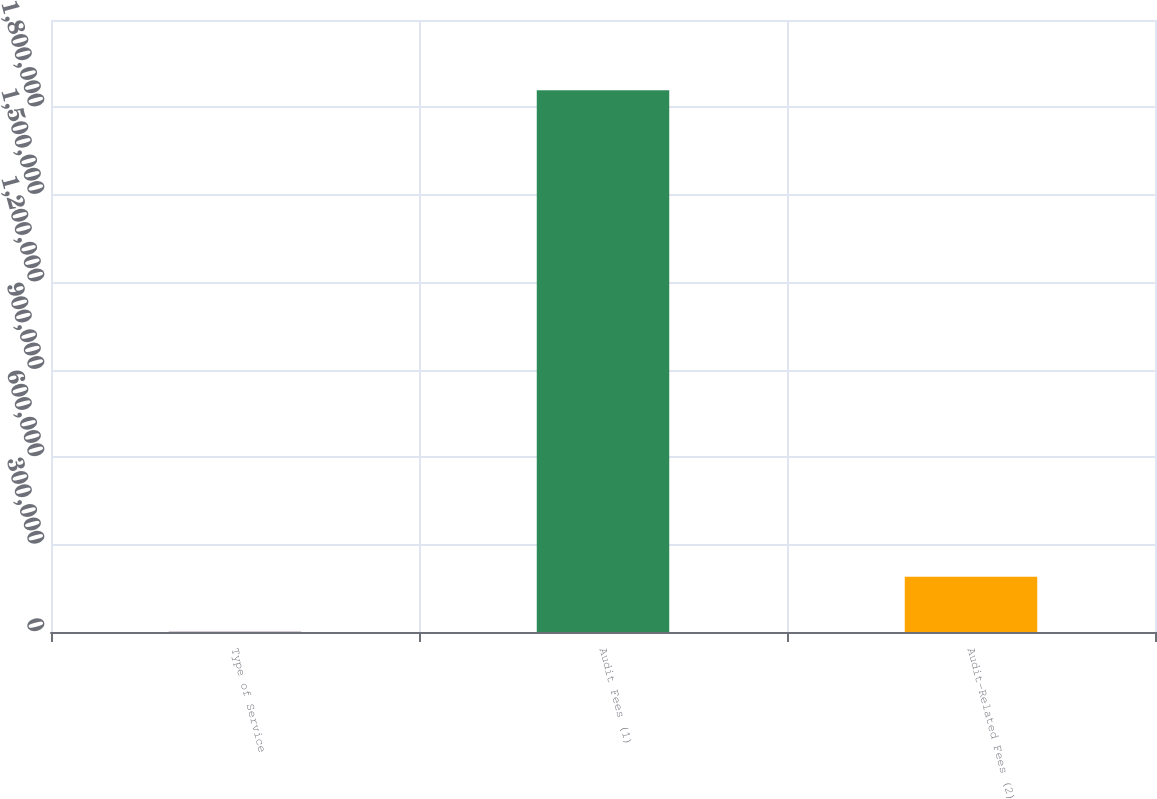Convert chart to OTSL. <chart><loc_0><loc_0><loc_500><loc_500><bar_chart><fcel>Type of Service<fcel>Audit Fees (1)<fcel>Audit-Related Fees (2)<nl><fcel>2013<fcel>1.85927e+06<fcel>189990<nl></chart> 